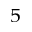<formula> <loc_0><loc_0><loc_500><loc_500>_ { 5 }</formula> 